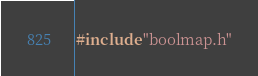<code> <loc_0><loc_0><loc_500><loc_500><_C++_>#include "boolmap.h"
</code> 